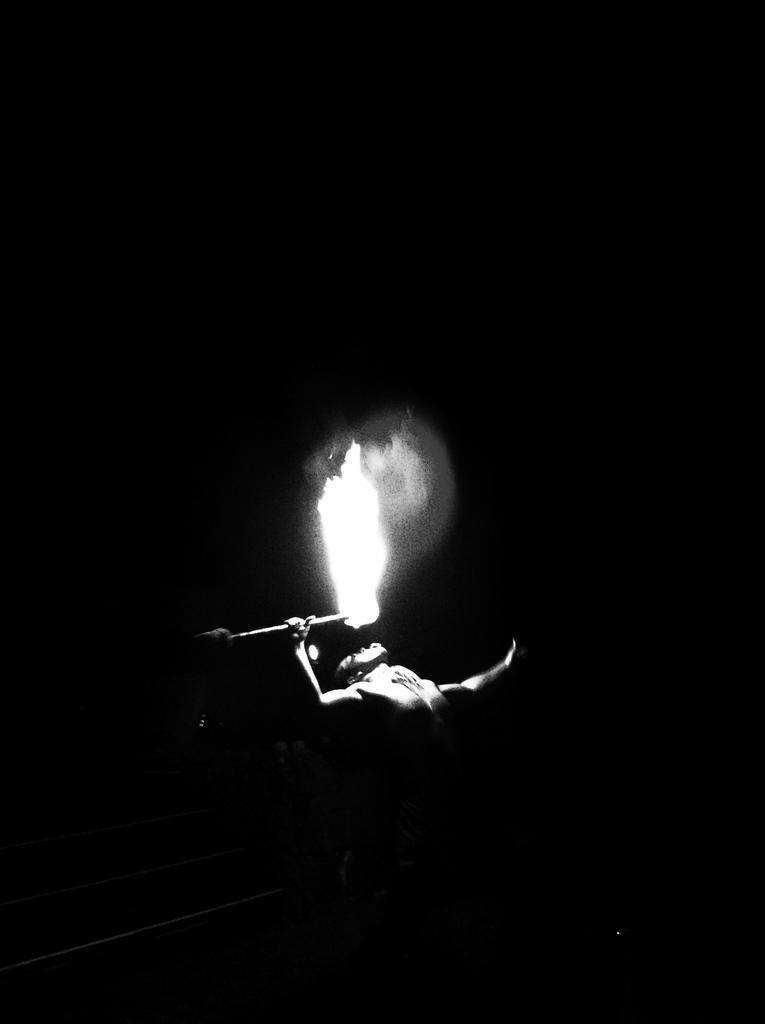Can you describe this image briefly? In this image the background is dark. In the middle of the image there is a man and he is holding a firestick with fire in his hands. 